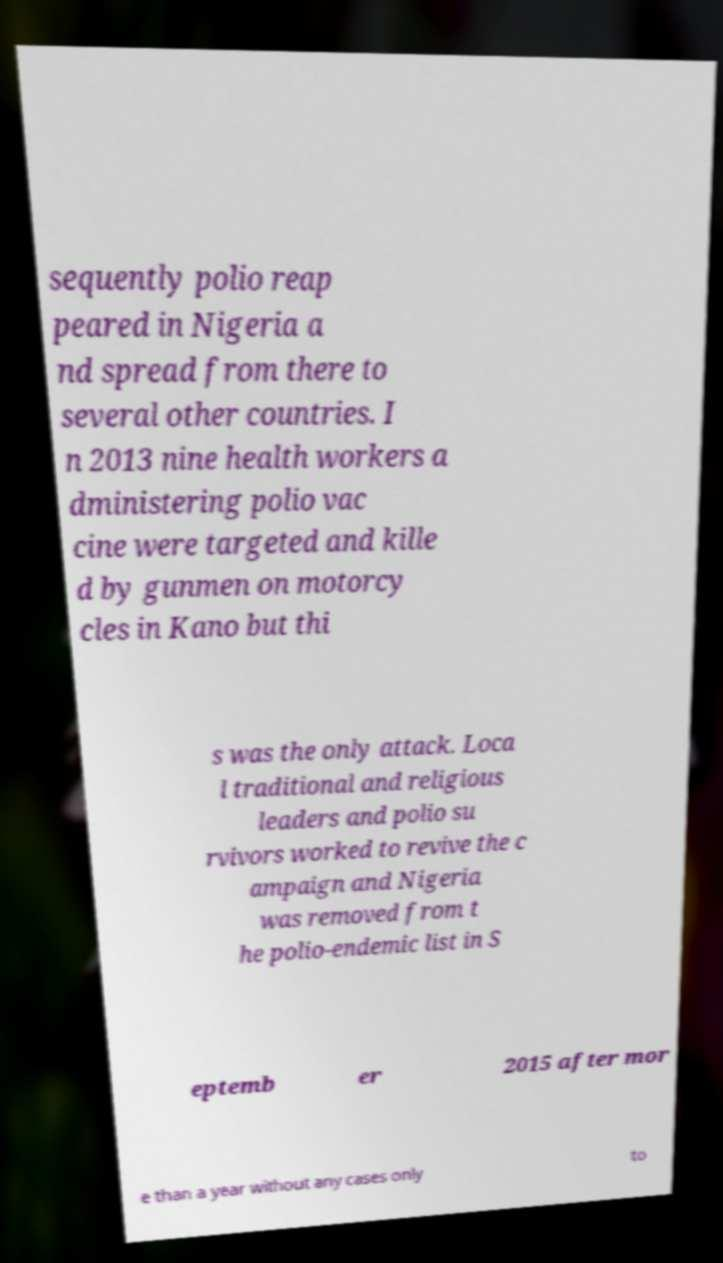There's text embedded in this image that I need extracted. Can you transcribe it verbatim? sequently polio reap peared in Nigeria a nd spread from there to several other countries. I n 2013 nine health workers a dministering polio vac cine were targeted and kille d by gunmen on motorcy cles in Kano but thi s was the only attack. Loca l traditional and religious leaders and polio su rvivors worked to revive the c ampaign and Nigeria was removed from t he polio-endemic list in S eptemb er 2015 after mor e than a year without any cases only to 